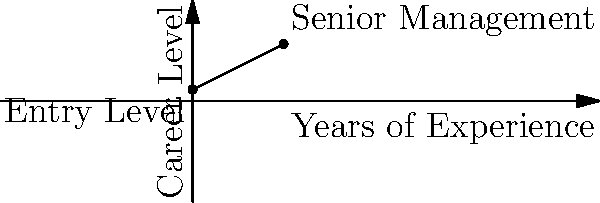In an organization's career growth model, the slope of a line represents the rate of progression from entry-level to senior management positions. Given that an employee starts at career level 1 and reaches level 5 after 8 years, what is the ethical implication of this growth rate, and how would you calculate the slope of this career trajectory? To answer this question, we need to follow these steps:

1. Identify the points on the graph:
   - Starting point: (0, 1) - Entry Level
   - Ending point: (8, 5) - Senior Management

2. Calculate the slope using the formula:
   $$ \text{slope} = \frac{\text{change in y}}{\text{change in x}} = \frac{y_2 - y_1}{x_2 - x_1} $$

   $$ \text{slope} = \frac{5 - 1}{8 - 0} = \frac{4}{8} = 0.5 $$

3. Interpret the slope:
   The slope of 0.5 means that for each year of experience, an employee's career level increases by 0.5 units on average.

4. Ethical implications:
   - Consistency: This linear model suggests a consistent rate of progression, which could be seen as fair and transparent.
   - Predictability: Employees can anticipate their career growth, potentially increasing job satisfaction and retention.
   - Limitations: The model doesn't account for individual performance differences or the varying complexity of roles at higher levels.
   - Equity: It may not reflect the diverse paths and paces at which different individuals develop their careers.

5. Ethical considerations:
   - Is this one-size-fits-all approach truly equitable?
   - Does it allow for recognition of exceptional performance or specialized skills?
   - How might this impact diversity and inclusion efforts in reaching senior management?
   - Should there be a more nuanced approach to career progression that considers multiple factors?

From an HR perspective informed by philosophical ethics, it's important to balance the benefits of a clear, consistent model with the need for flexibility and individual consideration in career development.
Answer: Slope = 0.5; Ethical implications: consistent but potentially oversimplified career progression model. 